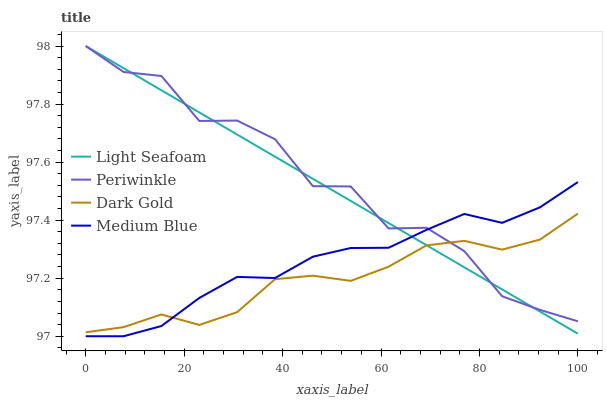Does Dark Gold have the minimum area under the curve?
Answer yes or no. Yes. Does Periwinkle have the maximum area under the curve?
Answer yes or no. Yes. Does Light Seafoam have the minimum area under the curve?
Answer yes or no. No. Does Light Seafoam have the maximum area under the curve?
Answer yes or no. No. Is Light Seafoam the smoothest?
Answer yes or no. Yes. Is Periwinkle the roughest?
Answer yes or no. Yes. Is Periwinkle the smoothest?
Answer yes or no. No. Is Light Seafoam the roughest?
Answer yes or no. No. Does Medium Blue have the lowest value?
Answer yes or no. Yes. Does Light Seafoam have the lowest value?
Answer yes or no. No. Does Periwinkle have the highest value?
Answer yes or no. Yes. Does Dark Gold have the highest value?
Answer yes or no. No. Does Dark Gold intersect Periwinkle?
Answer yes or no. Yes. Is Dark Gold less than Periwinkle?
Answer yes or no. No. Is Dark Gold greater than Periwinkle?
Answer yes or no. No. 